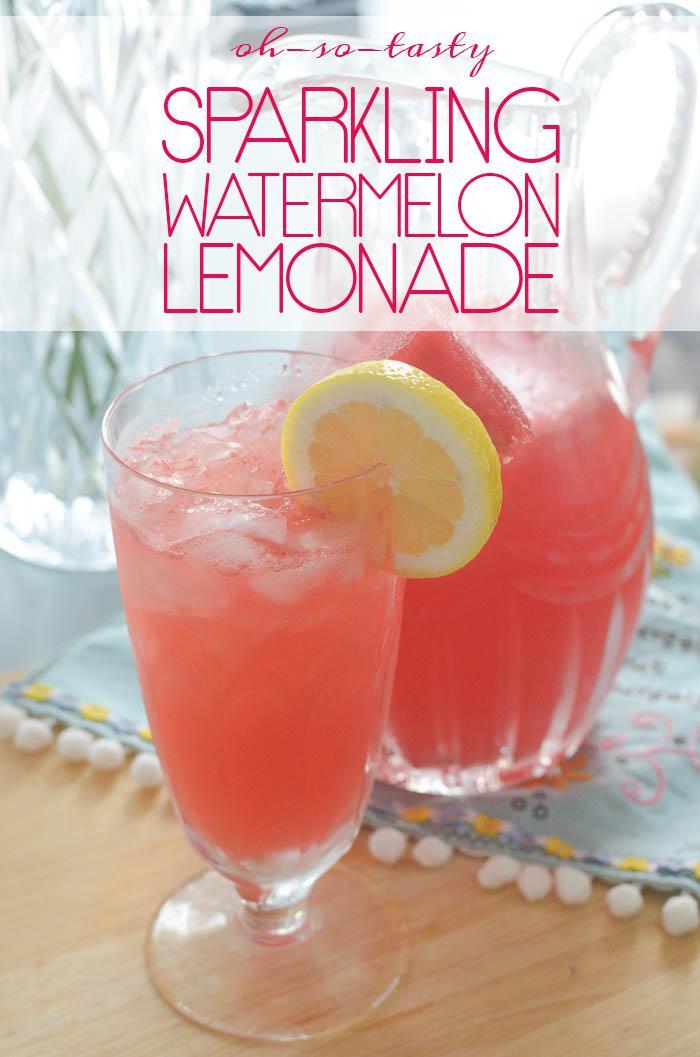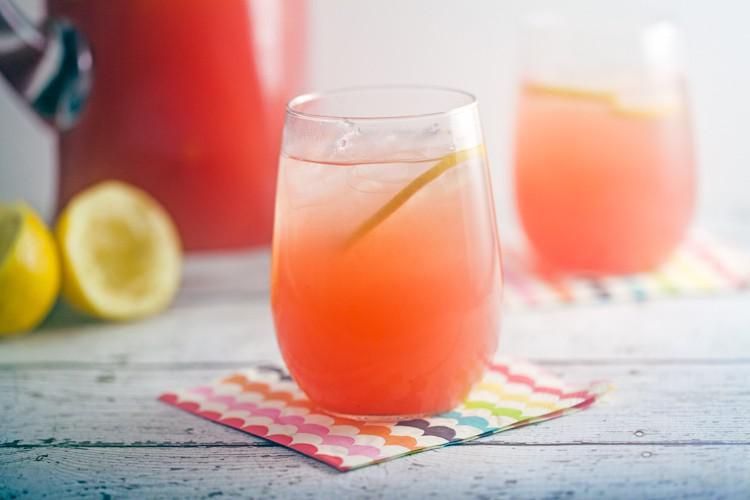The first image is the image on the left, the second image is the image on the right. Examine the images to the left and right. Is the description "All the images show drinks with straws in them." accurate? Answer yes or no. No. The first image is the image on the left, the second image is the image on the right. Analyze the images presented: Is the assertion "Fruity drinks are garnished with fruit and striped straws." valid? Answer yes or no. No. 